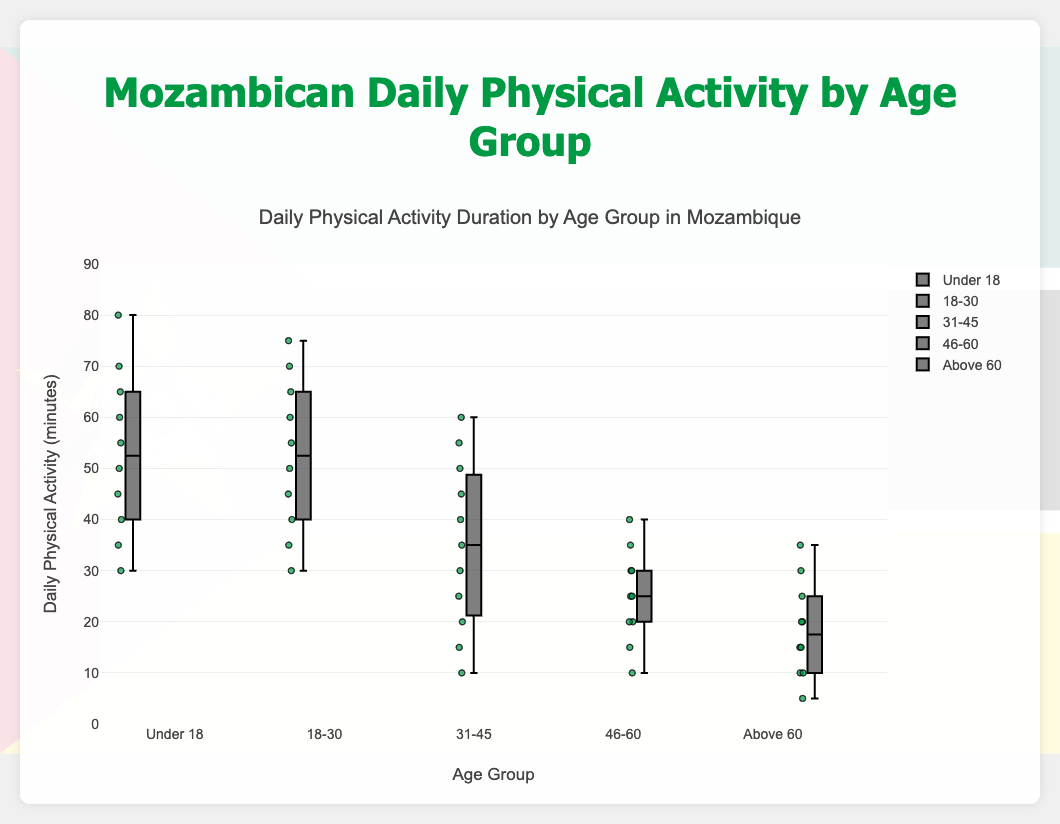What is the title of the figure? The title is typically displayed at the top of the figure.
Answer: Daily Physical Activity Duration by Age Group in Mozambique Which age group shows the highest median daily physical activity duration? The median is represented by the line within each box. The "Under 18" age group has the highest median line.
Answer: Under 18 For the "18-30" age group, what is the range of the data points? The range is calculated by subtracting the minimum value from the maximum value in the box plot. The values range from 30 to 75 minutes.
Answer: 45 minutes (75 - 30) How do the interquartile ranges (IQR) of "31-45" and "46-60" compare, and which one is larger? The interquartile range is the length of the box, representing the middle 50% of the data points. For "31-45", it ranges from 15 to 50, for "46-60" it ranges from 15 to 35.
Answer: 31-45 is larger Which age group has the smallest spread of data, and what could this indicate? Spread is indicated by the length of the whiskers and the box. "Above 60" has the smallest spread. This could indicate less variability in daily physical activity within this age group.
Answer: Above 60 Do any age groups have outliers, and if so, which ones? Outliers are points outside the whiskers. "Under 18" has an outlier at approximately 30 minutes.
Answer: Under 18 What is the third quartile value (Q3) for the "46-60" age group? The third quartile is the top edge of the box. For "46-60", this value is around 30 minutes.
Answer: 30 minutes Compare the median physical activity duration between "18-30" and "31-45" age groups. Medians are the lines inside the boxes. "18-30" has a median around 52.5 minutes, while "31-45" has a median around 35 minutes.
Answer: "18-30" is higher What insights can be drawn about physical activity trends across age groups in Mozambique? Younger age groups tend to have higher and more variable physical activity, while older age groups have lower and less variable activity levels. This might reflect lifestyle changes related to age.
Answer: Younger are more active and variable, older are less active and consistent Is there a significant difference in the upper quartile (Q3) values between "Under 18" and "Above 60"? Q3 is the top edge of the box. "Under 18" has a Q3 around 65-70, while "Above 60" has a Q3 around 30-35. There is a significant difference.
Answer: Yes 